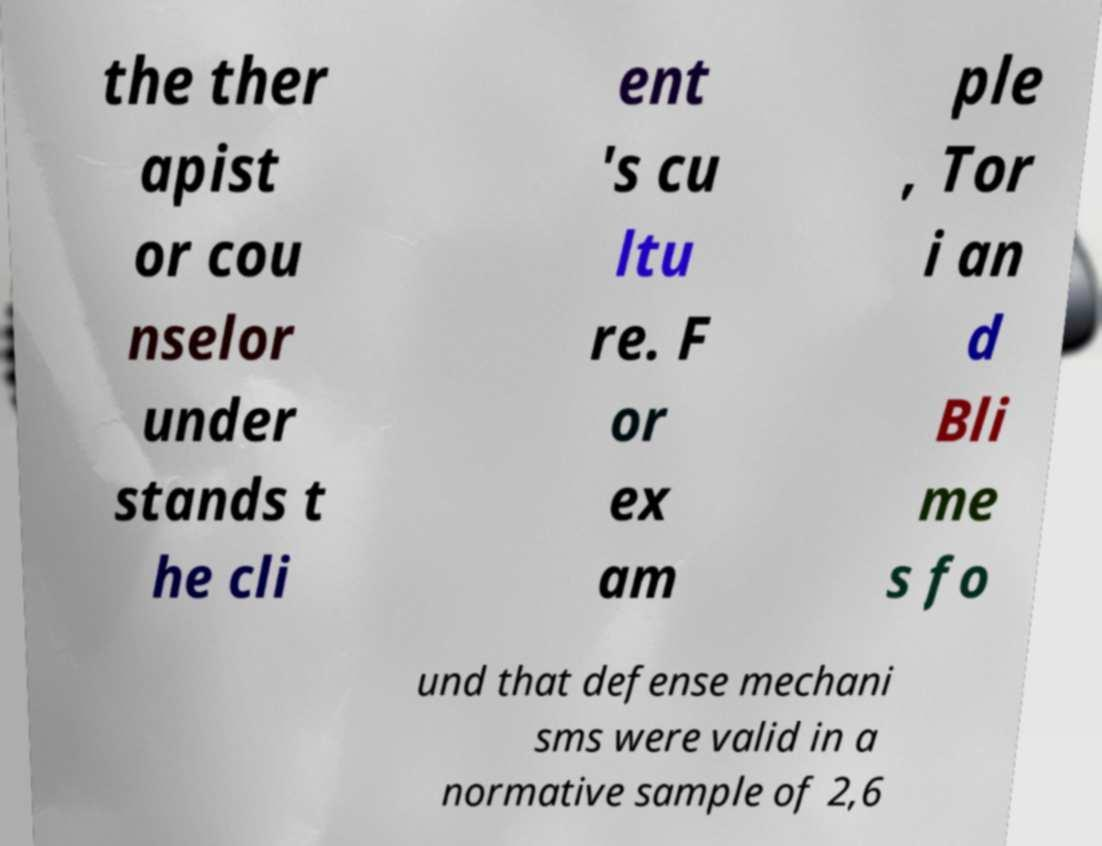Can you read and provide the text displayed in the image?This photo seems to have some interesting text. Can you extract and type it out for me? the ther apist or cou nselor under stands t he cli ent 's cu ltu re. F or ex am ple , Tor i an d Bli me s fo und that defense mechani sms were valid in a normative sample of 2,6 